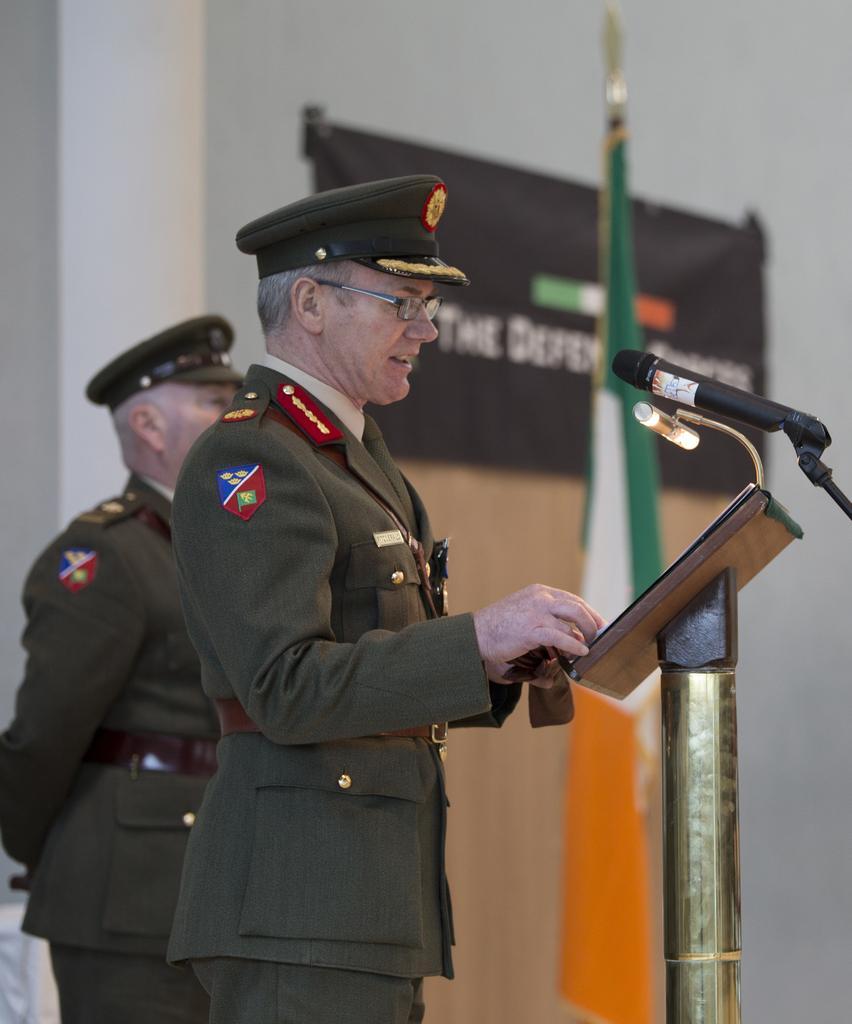Please provide a concise description of this image. This picture might be taken inside a conference hall. In this image, in the middle, we can see a man wearing a hat and he is also standing in front of the table and talking in front of a microphone. On the left side, we can also see a man. In the background, we can see a flag and hoardings and a wall which is in white color. 